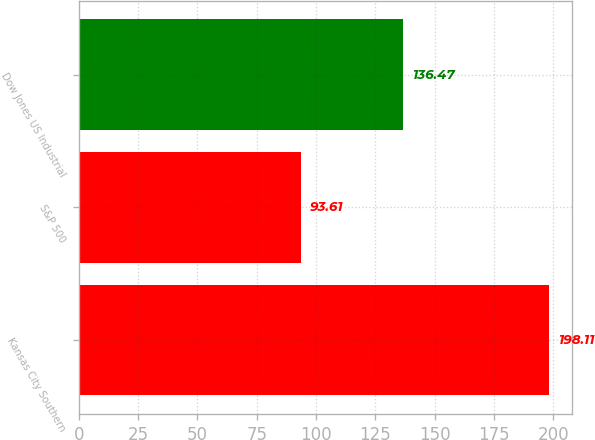<chart> <loc_0><loc_0><loc_500><loc_500><bar_chart><fcel>Kansas City Southern<fcel>S&P 500<fcel>Dow Jones US Industrial<nl><fcel>198.11<fcel>93.61<fcel>136.47<nl></chart> 